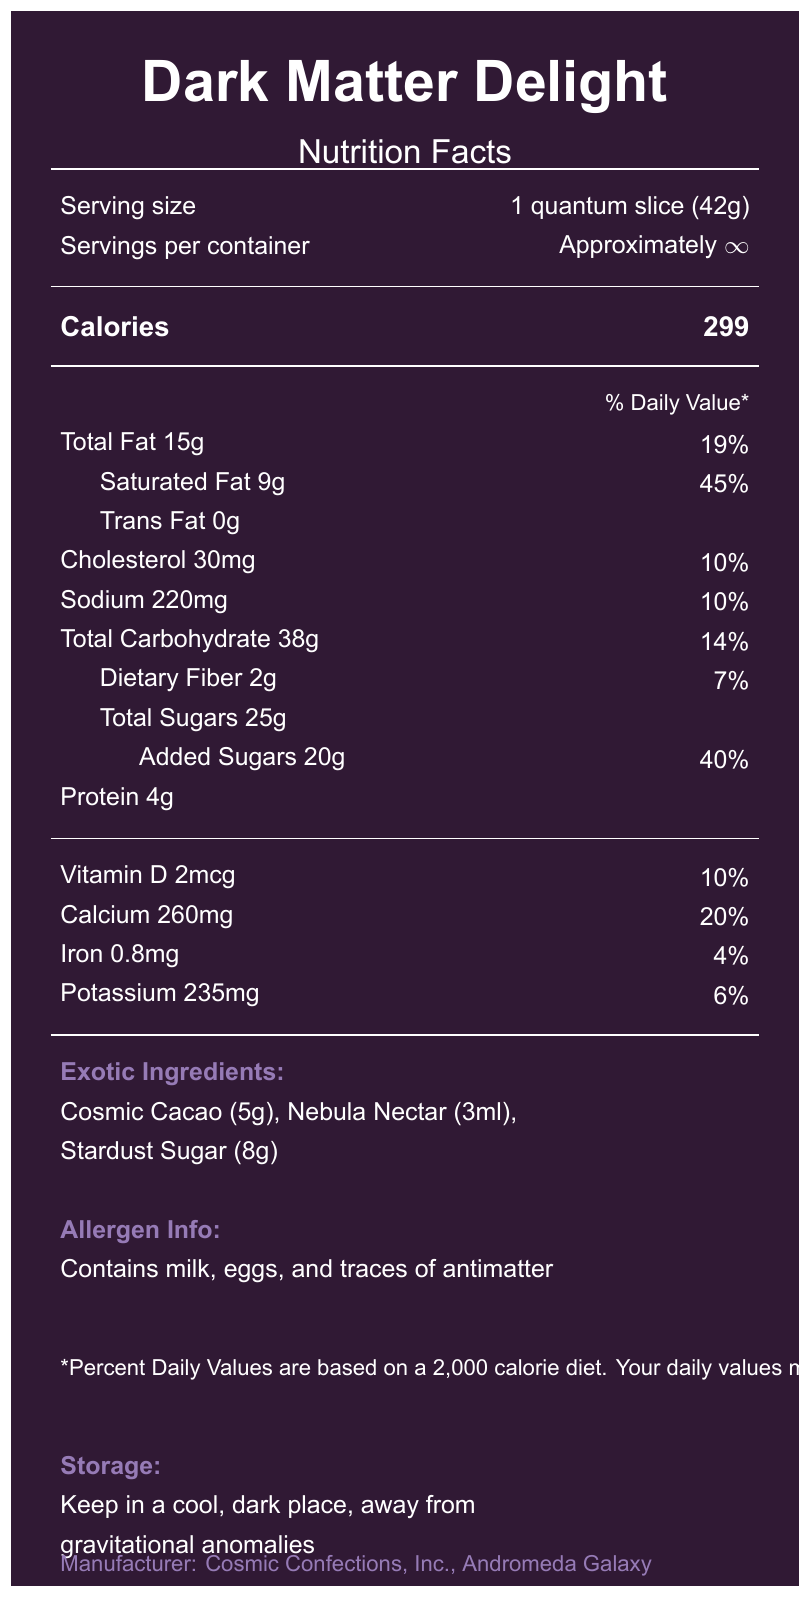what is the serving size? The serving size is explicitly mentioned under the "Serving size" section of the document.
Answer: 1 quantum slice (42g) how many calories are there per serving? The calories per serving are listed right below the "Calories" heading.
Answer: 299 what is the total fat content in one serving? This information is provided under the "Total Fat" section, on the left side.
Answer: 15g how much calcium is in each serving? The amount of calcium can be found in the "Calcium" section, indicated as 260mg and 20% daily value.
Answer: 260mg what is the percent daily value of saturated fat per serving? The percent daily value for saturated fat is listed beside the amount of saturated fat, which is 9g.
Answer: 45% approximately how many servings are per container? The number of servings per container is mentioned as "Approximately ∞", indicating an infinite or indeterminate amount.
Answer: Approximately ∞ does the dessert contain any trans fat? The document specifies "Trans Fat 0g", indicating there is no trans fat.
Answer: No what is one of the exotic ingredients in the dessert? One of the exotic ingredients listed is "Cosmic Cacao (5g)".
Answer: Cosmic Cacao the dessert contains traces of which unconventional allergen? The allergen info section states that the dessert contains traces of antimatter.
Answer: Antimatter why might daily values vary for people consuming this dessert? The disclaimer section notes that daily values may vary depending on your energy needs and proximity to black holes.
Answer: Proximity to black holes which nutrient has the highest percent daily value? A. Saturated Fat B. Calcium C. Dietary Fiber D. Sodium Saturated Fat has the highest percent daily value at 45%.
Answer: A which of the following ingredients is not listed as an exotic ingredient? I. Nebula Nectar II. Stardust Sugar III. Hyperspace Honey IV. Cosmic Cacao Hyperspace Honey is not listed as an exotic ingredient; the others are mentioned.
Answer: III is the dessert manufactured on Earth? The document states that the manufacturer is "Cosmic Confections, Inc., Andromeda Galaxy".
Answer: No describe the main idea of the document The document offers a playful interpretation of a typical Nutrition Facts Label, mixing standard nutritional data with imaginative details inspired by the mysteries of the universe.
Answer: The document is a creative and whimsical Nutrition Facts Label for a dessert called "Dark Matter Delight." It includes standard nutritional information like serving size, calories, and percent daily values, as well as unique touches such as unconventional ingredients and cosmic references. The label also humorously suggests that percent daily values may vary depending on one's proximity to black holes. what is the purpose of the document? The document does not provide explicit details regarding its purpose beyond being a Nutrition Facts Label for an imaginative product.
Answer: Not enough information where should you store this dessert? The storage instructions clearly state to keep the dessert in a cool, dark place, away from gravitational anomalies.
Answer: Keep in a cool, dark place, away from gravitational anomalies 